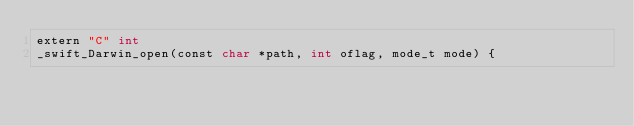<code> <loc_0><loc_0><loc_500><loc_500><_ObjectiveC_>extern "C" int 
_swift_Darwin_open(const char *path, int oflag, mode_t mode) {</code> 